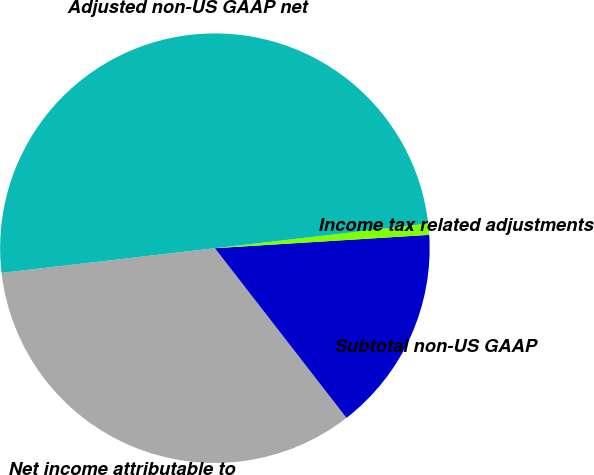Convert chart to OTSL. <chart><loc_0><loc_0><loc_500><loc_500><pie_chart><fcel>Net income attributable to<fcel>Subtotal non-US GAAP<fcel>Income tax related adjustments<fcel>Adjusted non-US GAAP net<nl><fcel>33.66%<fcel>15.49%<fcel>0.84%<fcel>50.0%<nl></chart> 